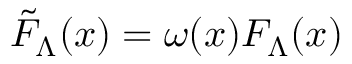Convert formula to latex. <formula><loc_0><loc_0><loc_500><loc_500>\tilde { F } _ { \Lambda } ( x ) = \omega ( x ) F _ { \Lambda } ( x )</formula> 